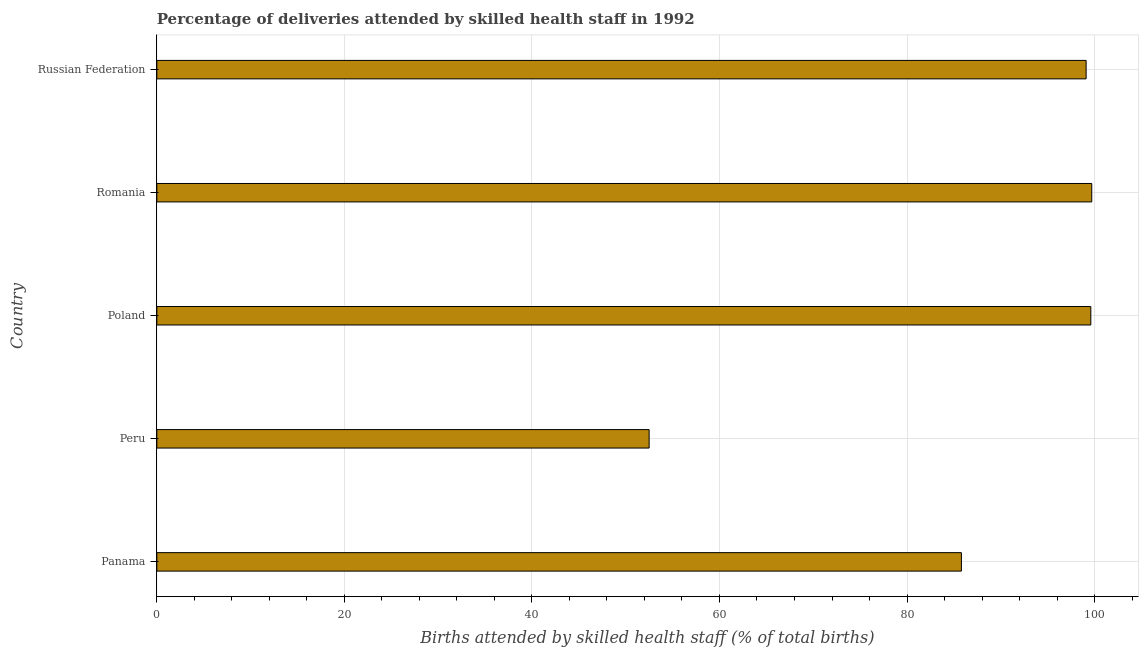Does the graph contain any zero values?
Offer a very short reply. No. What is the title of the graph?
Your answer should be compact. Percentage of deliveries attended by skilled health staff in 1992. What is the label or title of the X-axis?
Give a very brief answer. Births attended by skilled health staff (% of total births). What is the label or title of the Y-axis?
Your answer should be very brief. Country. What is the number of births attended by skilled health staff in Russian Federation?
Ensure brevity in your answer.  99.1. Across all countries, what is the maximum number of births attended by skilled health staff?
Offer a terse response. 99.7. Across all countries, what is the minimum number of births attended by skilled health staff?
Give a very brief answer. 52.5. In which country was the number of births attended by skilled health staff maximum?
Provide a succinct answer. Romania. In which country was the number of births attended by skilled health staff minimum?
Keep it short and to the point. Peru. What is the sum of the number of births attended by skilled health staff?
Your answer should be compact. 436.7. What is the difference between the number of births attended by skilled health staff in Panama and Poland?
Give a very brief answer. -13.8. What is the average number of births attended by skilled health staff per country?
Your answer should be compact. 87.34. What is the median number of births attended by skilled health staff?
Your answer should be very brief. 99.1. What is the ratio of the number of births attended by skilled health staff in Panama to that in Romania?
Your response must be concise. 0.86. Is the number of births attended by skilled health staff in Panama less than that in Romania?
Offer a terse response. Yes. Is the difference between the number of births attended by skilled health staff in Peru and Romania greater than the difference between any two countries?
Your response must be concise. Yes. What is the difference between the highest and the second highest number of births attended by skilled health staff?
Your answer should be compact. 0.1. Is the sum of the number of births attended by skilled health staff in Peru and Poland greater than the maximum number of births attended by skilled health staff across all countries?
Make the answer very short. Yes. What is the difference between the highest and the lowest number of births attended by skilled health staff?
Provide a short and direct response. 47.2. What is the difference between two consecutive major ticks on the X-axis?
Give a very brief answer. 20. What is the Births attended by skilled health staff (% of total births) of Panama?
Provide a short and direct response. 85.8. What is the Births attended by skilled health staff (% of total births) of Peru?
Give a very brief answer. 52.5. What is the Births attended by skilled health staff (% of total births) in Poland?
Your answer should be compact. 99.6. What is the Births attended by skilled health staff (% of total births) of Romania?
Your response must be concise. 99.7. What is the Births attended by skilled health staff (% of total births) of Russian Federation?
Your response must be concise. 99.1. What is the difference between the Births attended by skilled health staff (% of total births) in Panama and Peru?
Your answer should be very brief. 33.3. What is the difference between the Births attended by skilled health staff (% of total births) in Panama and Poland?
Ensure brevity in your answer.  -13.8. What is the difference between the Births attended by skilled health staff (% of total births) in Panama and Romania?
Make the answer very short. -13.9. What is the difference between the Births attended by skilled health staff (% of total births) in Panama and Russian Federation?
Your response must be concise. -13.3. What is the difference between the Births attended by skilled health staff (% of total births) in Peru and Poland?
Your answer should be compact. -47.1. What is the difference between the Births attended by skilled health staff (% of total births) in Peru and Romania?
Your answer should be compact. -47.2. What is the difference between the Births attended by skilled health staff (% of total births) in Peru and Russian Federation?
Your response must be concise. -46.6. What is the difference between the Births attended by skilled health staff (% of total births) in Poland and Russian Federation?
Offer a terse response. 0.5. What is the ratio of the Births attended by skilled health staff (% of total births) in Panama to that in Peru?
Make the answer very short. 1.63. What is the ratio of the Births attended by skilled health staff (% of total births) in Panama to that in Poland?
Give a very brief answer. 0.86. What is the ratio of the Births attended by skilled health staff (% of total births) in Panama to that in Romania?
Offer a terse response. 0.86. What is the ratio of the Births attended by skilled health staff (% of total births) in Panama to that in Russian Federation?
Offer a very short reply. 0.87. What is the ratio of the Births attended by skilled health staff (% of total births) in Peru to that in Poland?
Your answer should be very brief. 0.53. What is the ratio of the Births attended by skilled health staff (% of total births) in Peru to that in Romania?
Ensure brevity in your answer.  0.53. What is the ratio of the Births attended by skilled health staff (% of total births) in Peru to that in Russian Federation?
Offer a very short reply. 0.53. What is the ratio of the Births attended by skilled health staff (% of total births) in Poland to that in Russian Federation?
Give a very brief answer. 1. 